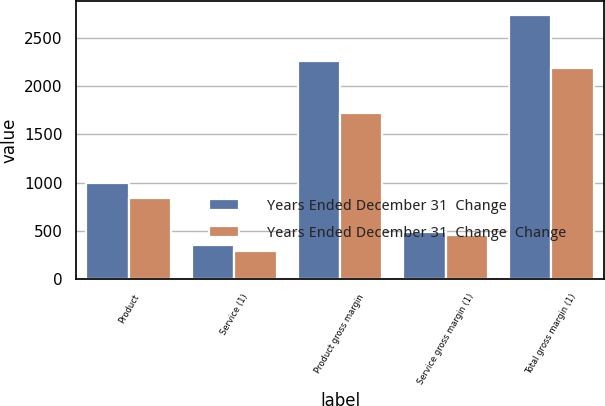Convert chart. <chart><loc_0><loc_0><loc_500><loc_500><stacked_bar_chart><ecel><fcel>Product<fcel>Service (1)<fcel>Product gross margin<fcel>Service gross margin (1)<fcel>Total gross margin (1)<nl><fcel>Years Ended December 31  Change<fcel>1000.9<fcel>350.6<fcel>2257.8<fcel>484<fcel>2741.8<nl><fcel>Years Ended December 31  Change  Change<fcel>841.7<fcel>291<fcel>1726.3<fcel>456.9<fcel>2183.2<nl></chart> 